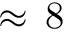Convert formula to latex. <formula><loc_0><loc_0><loc_500><loc_500>\approx \, 8</formula> 